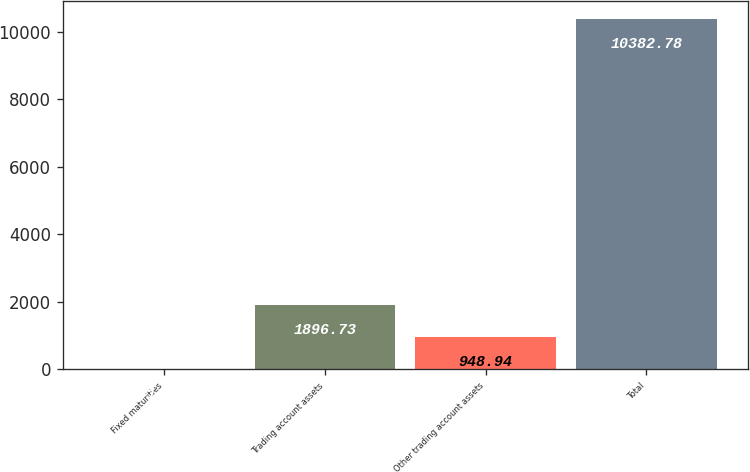Convert chart. <chart><loc_0><loc_0><loc_500><loc_500><bar_chart><fcel>Fixed maturities<fcel>Trading account assets<fcel>Other trading account assets<fcel>Total<nl><fcel>1.15<fcel>1896.73<fcel>948.94<fcel>10382.8<nl></chart> 